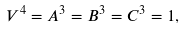Convert formula to latex. <formula><loc_0><loc_0><loc_500><loc_500>V ^ { 4 } = A ^ { 3 } = B ^ { 3 } = C ^ { 3 } = 1 ,</formula> 